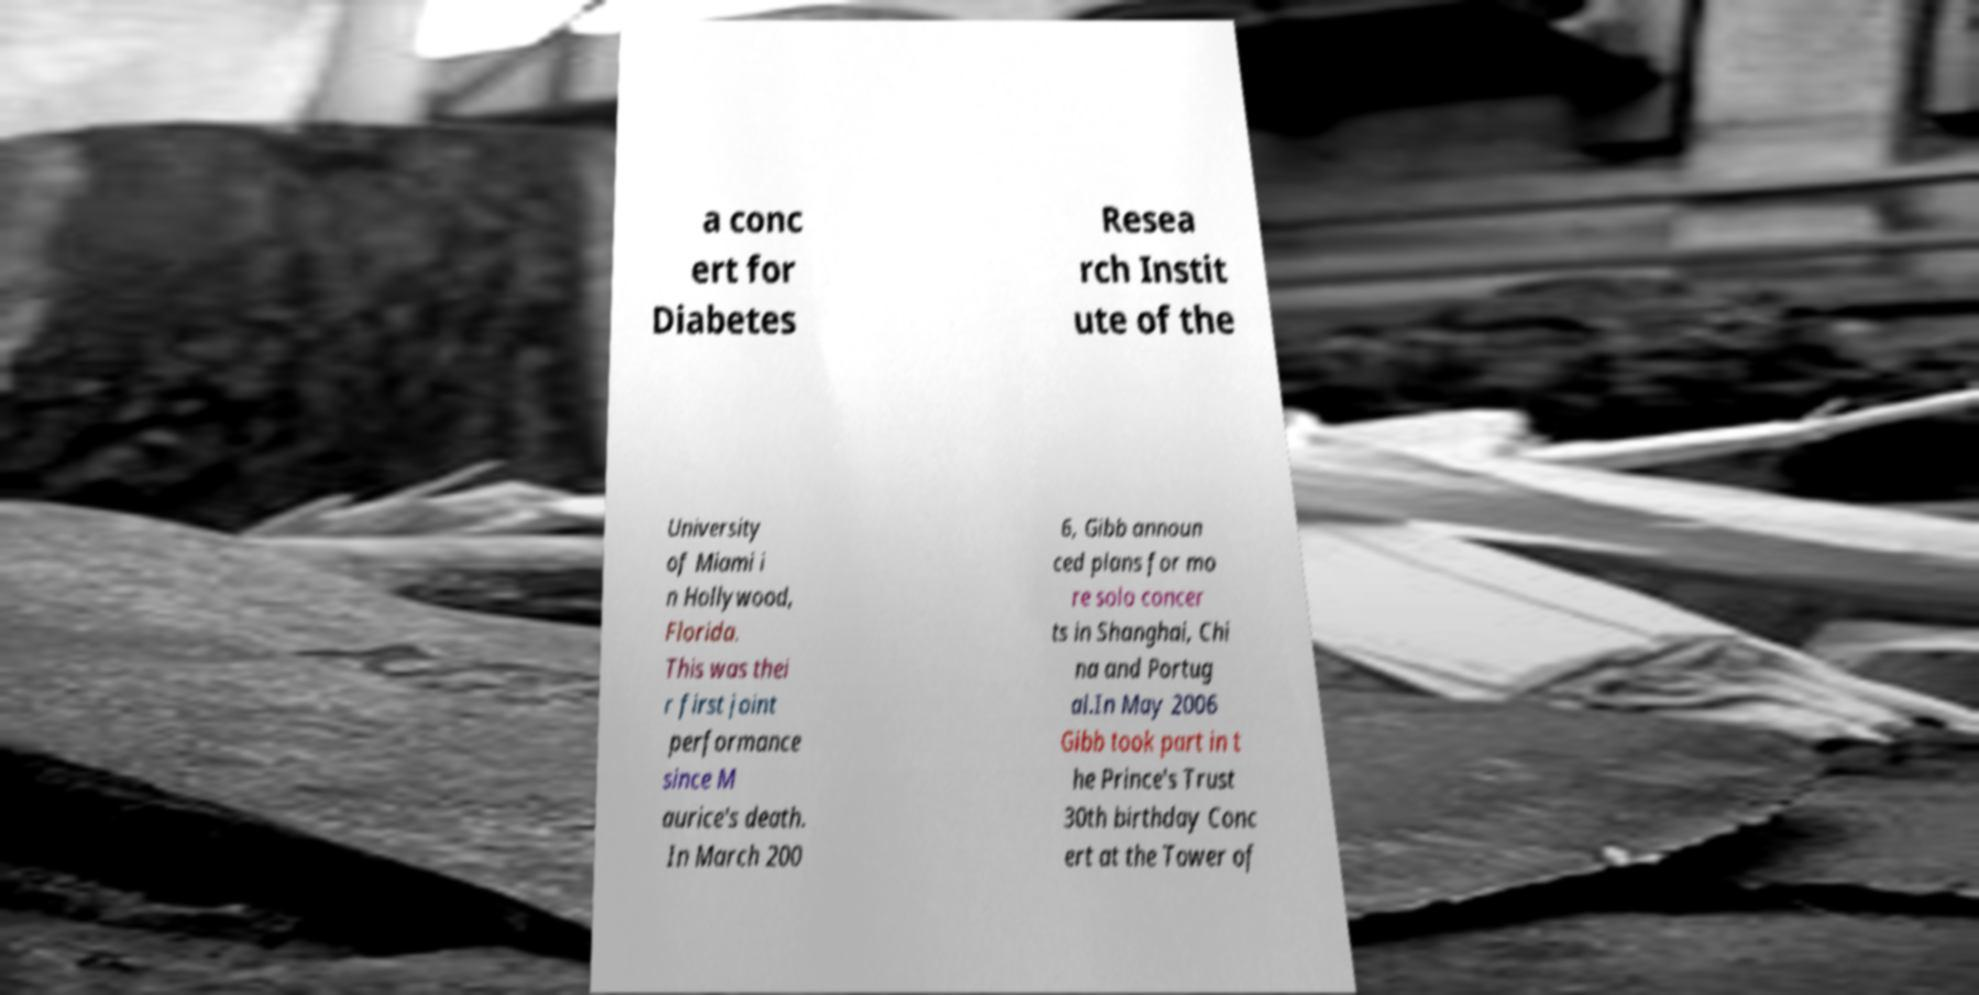Can you accurately transcribe the text from the provided image for me? a conc ert for Diabetes Resea rch Instit ute of the University of Miami i n Hollywood, Florida. This was thei r first joint performance since M aurice's death. In March 200 6, Gibb announ ced plans for mo re solo concer ts in Shanghai, Chi na and Portug al.In May 2006 Gibb took part in t he Prince's Trust 30th birthday Conc ert at the Tower of 